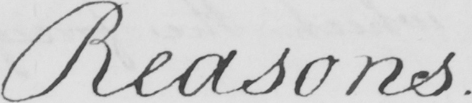Can you tell me what this handwritten text says? Reasons. 